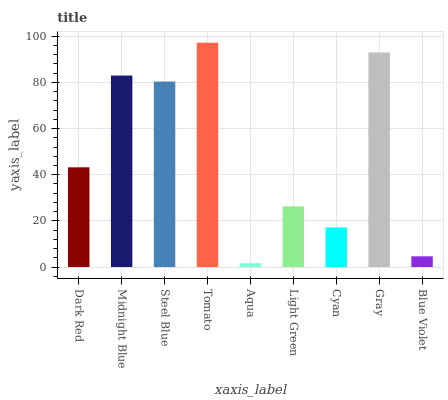Is Aqua the minimum?
Answer yes or no. Yes. Is Tomato the maximum?
Answer yes or no. Yes. Is Midnight Blue the minimum?
Answer yes or no. No. Is Midnight Blue the maximum?
Answer yes or no. No. Is Midnight Blue greater than Dark Red?
Answer yes or no. Yes. Is Dark Red less than Midnight Blue?
Answer yes or no. Yes. Is Dark Red greater than Midnight Blue?
Answer yes or no. No. Is Midnight Blue less than Dark Red?
Answer yes or no. No. Is Dark Red the high median?
Answer yes or no. Yes. Is Dark Red the low median?
Answer yes or no. Yes. Is Steel Blue the high median?
Answer yes or no. No. Is Light Green the low median?
Answer yes or no. No. 